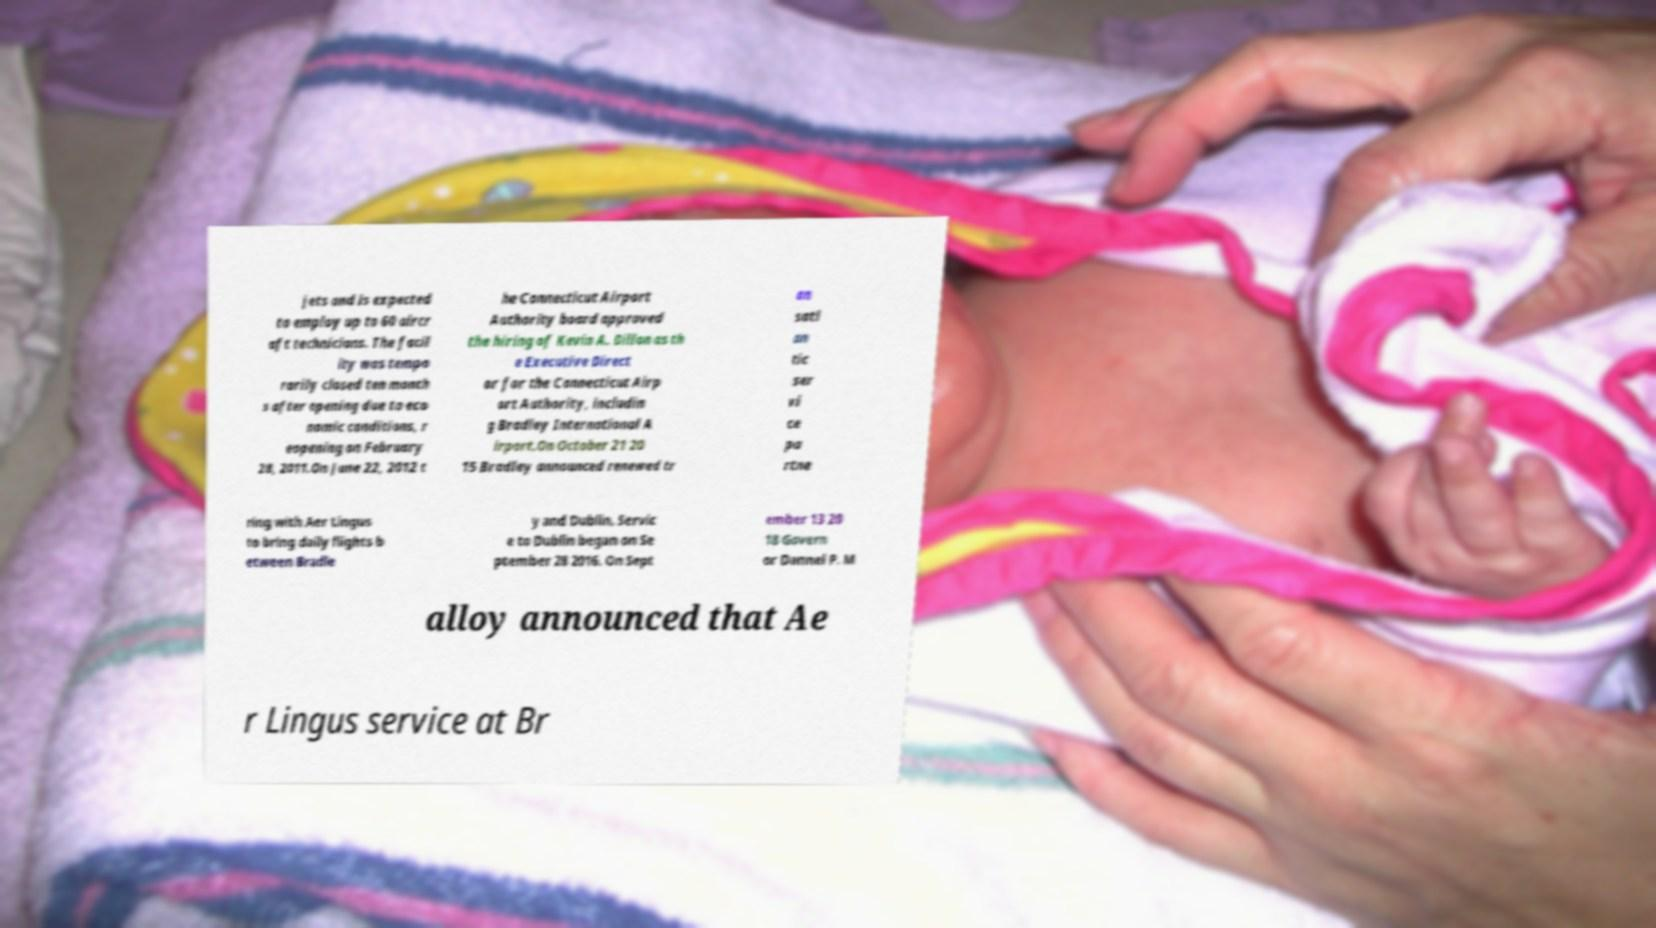Please read and relay the text visible in this image. What does it say? jets and is expected to employ up to 60 aircr aft technicians. The facil ity was tempo rarily closed ten month s after opening due to eco nomic conditions, r eopening on February 28, 2011.On June 22, 2012 t he Connecticut Airport Authority board approved the hiring of Kevin A. Dillon as th e Executive Direct or for the Connecticut Airp ort Authority, includin g Bradley International A irport.On October 21 20 15 Bradley announced renewed tr an satl an tic ser vi ce pa rtne ring with Aer Lingus to bring daily flights b etween Bradle y and Dublin. Servic e to Dublin began on Se ptember 28 2016. On Sept ember 13 20 18 Govern or Dannel P. M alloy announced that Ae r Lingus service at Br 